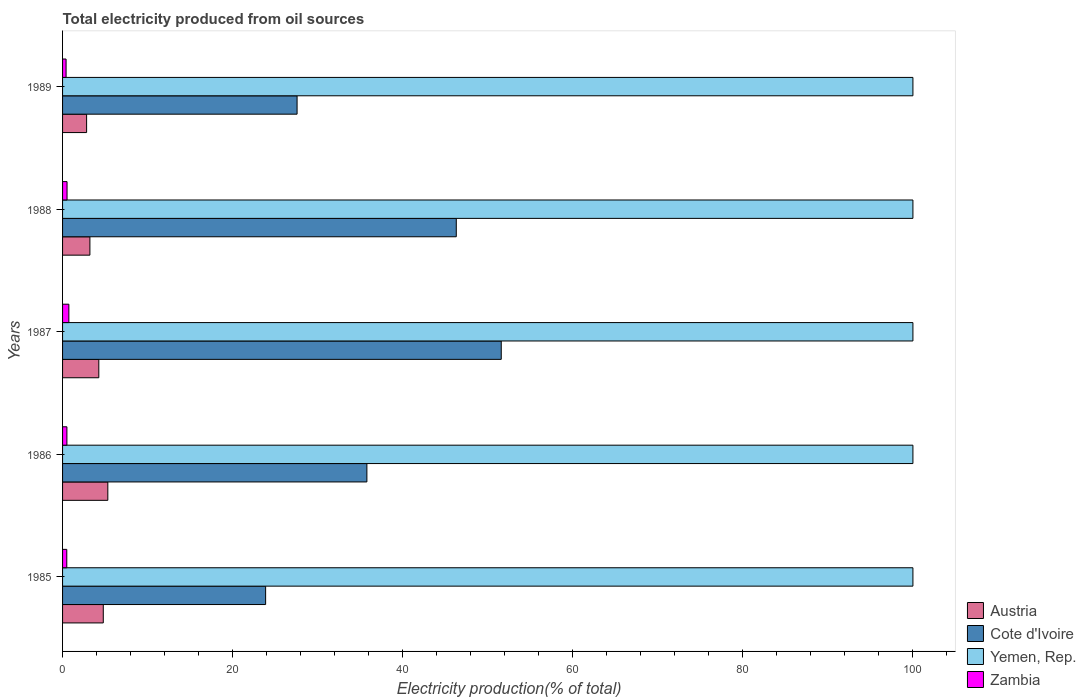How many different coloured bars are there?
Offer a very short reply. 4. Are the number of bars per tick equal to the number of legend labels?
Ensure brevity in your answer.  Yes. Are the number of bars on each tick of the Y-axis equal?
Provide a short and direct response. Yes. Across all years, what is the maximum total electricity produced in Cote d'Ivoire?
Your answer should be compact. 51.59. In which year was the total electricity produced in Yemen, Rep. minimum?
Provide a short and direct response. 1985. What is the total total electricity produced in Zambia in the graph?
Ensure brevity in your answer.  2.69. What is the difference between the total electricity produced in Austria in 1987 and the total electricity produced in Yemen, Rep. in 1986?
Provide a short and direct response. -95.74. What is the average total electricity produced in Austria per year?
Offer a terse response. 4.08. In the year 1987, what is the difference between the total electricity produced in Yemen, Rep. and total electricity produced in Zambia?
Your answer should be compact. 99.26. What is the ratio of the total electricity produced in Austria in 1985 to that in 1987?
Offer a very short reply. 1.12. Is the total electricity produced in Cote d'Ivoire in 1987 less than that in 1989?
Keep it short and to the point. No. Is the difference between the total electricity produced in Yemen, Rep. in 1987 and 1988 greater than the difference between the total electricity produced in Zambia in 1987 and 1988?
Your answer should be very brief. No. What is the difference between the highest and the second highest total electricity produced in Yemen, Rep.?
Make the answer very short. 0. What is the difference between the highest and the lowest total electricity produced in Zambia?
Offer a terse response. 0.33. In how many years, is the total electricity produced in Yemen, Rep. greater than the average total electricity produced in Yemen, Rep. taken over all years?
Offer a very short reply. 0. Is the sum of the total electricity produced in Austria in 1985 and 1988 greater than the maximum total electricity produced in Yemen, Rep. across all years?
Keep it short and to the point. No. Is it the case that in every year, the sum of the total electricity produced in Zambia and total electricity produced in Austria is greater than the sum of total electricity produced in Yemen, Rep. and total electricity produced in Cote d'Ivoire?
Ensure brevity in your answer.  Yes. What does the 2nd bar from the top in 1985 represents?
Offer a terse response. Yemen, Rep. What does the 2nd bar from the bottom in 1989 represents?
Ensure brevity in your answer.  Cote d'Ivoire. Is it the case that in every year, the sum of the total electricity produced in Yemen, Rep. and total electricity produced in Austria is greater than the total electricity produced in Cote d'Ivoire?
Give a very brief answer. Yes. How many bars are there?
Provide a succinct answer. 20. How many years are there in the graph?
Give a very brief answer. 5. Are the values on the major ticks of X-axis written in scientific E-notation?
Offer a very short reply. No. Does the graph contain any zero values?
Ensure brevity in your answer.  No. Does the graph contain grids?
Make the answer very short. No. Where does the legend appear in the graph?
Your answer should be compact. Bottom right. What is the title of the graph?
Provide a short and direct response. Total electricity produced from oil sources. Does "Equatorial Guinea" appear as one of the legend labels in the graph?
Your answer should be very brief. No. What is the label or title of the X-axis?
Ensure brevity in your answer.  Electricity production(% of total). What is the Electricity production(% of total) in Austria in 1985?
Ensure brevity in your answer.  4.79. What is the Electricity production(% of total) of Cote d'Ivoire in 1985?
Offer a terse response. 23.88. What is the Electricity production(% of total) in Yemen, Rep. in 1985?
Keep it short and to the point. 100. What is the Electricity production(% of total) of Zambia in 1985?
Your answer should be very brief. 0.5. What is the Electricity production(% of total) in Austria in 1986?
Your response must be concise. 5.32. What is the Electricity production(% of total) in Cote d'Ivoire in 1986?
Your answer should be very brief. 35.79. What is the Electricity production(% of total) in Yemen, Rep. in 1986?
Provide a succinct answer. 100. What is the Electricity production(% of total) in Zambia in 1986?
Your answer should be very brief. 0.51. What is the Electricity production(% of total) of Austria in 1987?
Your response must be concise. 4.26. What is the Electricity production(% of total) of Cote d'Ivoire in 1987?
Provide a short and direct response. 51.59. What is the Electricity production(% of total) in Zambia in 1987?
Make the answer very short. 0.74. What is the Electricity production(% of total) of Austria in 1988?
Keep it short and to the point. 3.22. What is the Electricity production(% of total) of Cote d'Ivoire in 1988?
Provide a succinct answer. 46.3. What is the Electricity production(% of total) in Yemen, Rep. in 1988?
Keep it short and to the point. 100. What is the Electricity production(% of total) in Zambia in 1988?
Offer a very short reply. 0.53. What is the Electricity production(% of total) in Austria in 1989?
Give a very brief answer. 2.83. What is the Electricity production(% of total) of Cote d'Ivoire in 1989?
Your answer should be compact. 27.58. What is the Electricity production(% of total) of Yemen, Rep. in 1989?
Provide a succinct answer. 100. What is the Electricity production(% of total) of Zambia in 1989?
Make the answer very short. 0.41. Across all years, what is the maximum Electricity production(% of total) of Austria?
Offer a terse response. 5.32. Across all years, what is the maximum Electricity production(% of total) in Cote d'Ivoire?
Ensure brevity in your answer.  51.59. Across all years, what is the maximum Electricity production(% of total) in Yemen, Rep.?
Give a very brief answer. 100. Across all years, what is the maximum Electricity production(% of total) of Zambia?
Offer a terse response. 0.74. Across all years, what is the minimum Electricity production(% of total) in Austria?
Ensure brevity in your answer.  2.83. Across all years, what is the minimum Electricity production(% of total) in Cote d'Ivoire?
Ensure brevity in your answer.  23.88. Across all years, what is the minimum Electricity production(% of total) of Yemen, Rep.?
Provide a short and direct response. 100. Across all years, what is the minimum Electricity production(% of total) in Zambia?
Your answer should be very brief. 0.41. What is the total Electricity production(% of total) in Austria in the graph?
Keep it short and to the point. 20.42. What is the total Electricity production(% of total) in Cote d'Ivoire in the graph?
Your response must be concise. 185.13. What is the total Electricity production(% of total) in Yemen, Rep. in the graph?
Your answer should be very brief. 500. What is the total Electricity production(% of total) of Zambia in the graph?
Ensure brevity in your answer.  2.69. What is the difference between the Electricity production(% of total) in Austria in 1985 and that in 1986?
Your answer should be compact. -0.54. What is the difference between the Electricity production(% of total) in Cote d'Ivoire in 1985 and that in 1986?
Your answer should be compact. -11.91. What is the difference between the Electricity production(% of total) in Yemen, Rep. in 1985 and that in 1986?
Make the answer very short. 0. What is the difference between the Electricity production(% of total) in Zambia in 1985 and that in 1986?
Your answer should be very brief. -0.01. What is the difference between the Electricity production(% of total) in Austria in 1985 and that in 1987?
Keep it short and to the point. 0.52. What is the difference between the Electricity production(% of total) of Cote d'Ivoire in 1985 and that in 1987?
Offer a terse response. -27.71. What is the difference between the Electricity production(% of total) in Yemen, Rep. in 1985 and that in 1987?
Your answer should be compact. 0. What is the difference between the Electricity production(% of total) in Zambia in 1985 and that in 1987?
Keep it short and to the point. -0.24. What is the difference between the Electricity production(% of total) in Austria in 1985 and that in 1988?
Ensure brevity in your answer.  1.57. What is the difference between the Electricity production(% of total) in Cote d'Ivoire in 1985 and that in 1988?
Your response must be concise. -22.42. What is the difference between the Electricity production(% of total) in Yemen, Rep. in 1985 and that in 1988?
Ensure brevity in your answer.  0. What is the difference between the Electricity production(% of total) in Zambia in 1985 and that in 1988?
Give a very brief answer. -0.03. What is the difference between the Electricity production(% of total) in Austria in 1985 and that in 1989?
Offer a terse response. 1.96. What is the difference between the Electricity production(% of total) in Cote d'Ivoire in 1985 and that in 1989?
Give a very brief answer. -3.7. What is the difference between the Electricity production(% of total) of Yemen, Rep. in 1985 and that in 1989?
Your answer should be very brief. 0. What is the difference between the Electricity production(% of total) in Zambia in 1985 and that in 1989?
Provide a short and direct response. 0.08. What is the difference between the Electricity production(% of total) of Austria in 1986 and that in 1987?
Ensure brevity in your answer.  1.06. What is the difference between the Electricity production(% of total) of Cote d'Ivoire in 1986 and that in 1987?
Make the answer very short. -15.8. What is the difference between the Electricity production(% of total) of Zambia in 1986 and that in 1987?
Ensure brevity in your answer.  -0.23. What is the difference between the Electricity production(% of total) of Austria in 1986 and that in 1988?
Provide a short and direct response. 2.11. What is the difference between the Electricity production(% of total) of Cote d'Ivoire in 1986 and that in 1988?
Ensure brevity in your answer.  -10.51. What is the difference between the Electricity production(% of total) of Yemen, Rep. in 1986 and that in 1988?
Offer a terse response. 0. What is the difference between the Electricity production(% of total) in Zambia in 1986 and that in 1988?
Ensure brevity in your answer.  -0.02. What is the difference between the Electricity production(% of total) of Austria in 1986 and that in 1989?
Keep it short and to the point. 2.5. What is the difference between the Electricity production(% of total) of Cote d'Ivoire in 1986 and that in 1989?
Keep it short and to the point. 8.21. What is the difference between the Electricity production(% of total) of Yemen, Rep. in 1986 and that in 1989?
Give a very brief answer. 0. What is the difference between the Electricity production(% of total) of Zambia in 1986 and that in 1989?
Ensure brevity in your answer.  0.1. What is the difference between the Electricity production(% of total) of Austria in 1987 and that in 1988?
Your response must be concise. 1.05. What is the difference between the Electricity production(% of total) in Cote d'Ivoire in 1987 and that in 1988?
Ensure brevity in your answer.  5.29. What is the difference between the Electricity production(% of total) in Yemen, Rep. in 1987 and that in 1988?
Give a very brief answer. 0. What is the difference between the Electricity production(% of total) of Zambia in 1987 and that in 1988?
Your answer should be very brief. 0.21. What is the difference between the Electricity production(% of total) of Austria in 1987 and that in 1989?
Make the answer very short. 1.43. What is the difference between the Electricity production(% of total) in Cote d'Ivoire in 1987 and that in 1989?
Give a very brief answer. 24.01. What is the difference between the Electricity production(% of total) of Yemen, Rep. in 1987 and that in 1989?
Give a very brief answer. 0. What is the difference between the Electricity production(% of total) in Zambia in 1987 and that in 1989?
Ensure brevity in your answer.  0.33. What is the difference between the Electricity production(% of total) in Austria in 1988 and that in 1989?
Offer a very short reply. 0.39. What is the difference between the Electricity production(% of total) of Cote d'Ivoire in 1988 and that in 1989?
Your answer should be compact. 18.72. What is the difference between the Electricity production(% of total) of Zambia in 1988 and that in 1989?
Provide a short and direct response. 0.11. What is the difference between the Electricity production(% of total) of Austria in 1985 and the Electricity production(% of total) of Cote d'Ivoire in 1986?
Offer a terse response. -31. What is the difference between the Electricity production(% of total) in Austria in 1985 and the Electricity production(% of total) in Yemen, Rep. in 1986?
Offer a very short reply. -95.21. What is the difference between the Electricity production(% of total) of Austria in 1985 and the Electricity production(% of total) of Zambia in 1986?
Keep it short and to the point. 4.28. What is the difference between the Electricity production(% of total) in Cote d'Ivoire in 1985 and the Electricity production(% of total) in Yemen, Rep. in 1986?
Provide a succinct answer. -76.12. What is the difference between the Electricity production(% of total) in Cote d'Ivoire in 1985 and the Electricity production(% of total) in Zambia in 1986?
Ensure brevity in your answer.  23.37. What is the difference between the Electricity production(% of total) in Yemen, Rep. in 1985 and the Electricity production(% of total) in Zambia in 1986?
Your answer should be very brief. 99.49. What is the difference between the Electricity production(% of total) in Austria in 1985 and the Electricity production(% of total) in Cote d'Ivoire in 1987?
Ensure brevity in your answer.  -46.8. What is the difference between the Electricity production(% of total) of Austria in 1985 and the Electricity production(% of total) of Yemen, Rep. in 1987?
Make the answer very short. -95.21. What is the difference between the Electricity production(% of total) of Austria in 1985 and the Electricity production(% of total) of Zambia in 1987?
Your answer should be compact. 4.05. What is the difference between the Electricity production(% of total) in Cote d'Ivoire in 1985 and the Electricity production(% of total) in Yemen, Rep. in 1987?
Keep it short and to the point. -76.12. What is the difference between the Electricity production(% of total) in Cote d'Ivoire in 1985 and the Electricity production(% of total) in Zambia in 1987?
Make the answer very short. 23.14. What is the difference between the Electricity production(% of total) of Yemen, Rep. in 1985 and the Electricity production(% of total) of Zambia in 1987?
Make the answer very short. 99.26. What is the difference between the Electricity production(% of total) in Austria in 1985 and the Electricity production(% of total) in Cote d'Ivoire in 1988?
Provide a short and direct response. -41.51. What is the difference between the Electricity production(% of total) in Austria in 1985 and the Electricity production(% of total) in Yemen, Rep. in 1988?
Keep it short and to the point. -95.21. What is the difference between the Electricity production(% of total) of Austria in 1985 and the Electricity production(% of total) of Zambia in 1988?
Make the answer very short. 4.26. What is the difference between the Electricity production(% of total) of Cote d'Ivoire in 1985 and the Electricity production(% of total) of Yemen, Rep. in 1988?
Your response must be concise. -76.12. What is the difference between the Electricity production(% of total) in Cote d'Ivoire in 1985 and the Electricity production(% of total) in Zambia in 1988?
Your response must be concise. 23.35. What is the difference between the Electricity production(% of total) in Yemen, Rep. in 1985 and the Electricity production(% of total) in Zambia in 1988?
Give a very brief answer. 99.47. What is the difference between the Electricity production(% of total) in Austria in 1985 and the Electricity production(% of total) in Cote d'Ivoire in 1989?
Your answer should be very brief. -22.79. What is the difference between the Electricity production(% of total) of Austria in 1985 and the Electricity production(% of total) of Yemen, Rep. in 1989?
Your answer should be very brief. -95.21. What is the difference between the Electricity production(% of total) of Austria in 1985 and the Electricity production(% of total) of Zambia in 1989?
Keep it short and to the point. 4.37. What is the difference between the Electricity production(% of total) in Cote d'Ivoire in 1985 and the Electricity production(% of total) in Yemen, Rep. in 1989?
Your response must be concise. -76.12. What is the difference between the Electricity production(% of total) of Cote d'Ivoire in 1985 and the Electricity production(% of total) of Zambia in 1989?
Your answer should be compact. 23.47. What is the difference between the Electricity production(% of total) of Yemen, Rep. in 1985 and the Electricity production(% of total) of Zambia in 1989?
Offer a terse response. 99.59. What is the difference between the Electricity production(% of total) in Austria in 1986 and the Electricity production(% of total) in Cote d'Ivoire in 1987?
Ensure brevity in your answer.  -46.26. What is the difference between the Electricity production(% of total) of Austria in 1986 and the Electricity production(% of total) of Yemen, Rep. in 1987?
Offer a terse response. -94.68. What is the difference between the Electricity production(% of total) of Austria in 1986 and the Electricity production(% of total) of Zambia in 1987?
Provide a succinct answer. 4.58. What is the difference between the Electricity production(% of total) of Cote d'Ivoire in 1986 and the Electricity production(% of total) of Yemen, Rep. in 1987?
Offer a very short reply. -64.21. What is the difference between the Electricity production(% of total) of Cote d'Ivoire in 1986 and the Electricity production(% of total) of Zambia in 1987?
Provide a succinct answer. 35.05. What is the difference between the Electricity production(% of total) in Yemen, Rep. in 1986 and the Electricity production(% of total) in Zambia in 1987?
Offer a very short reply. 99.26. What is the difference between the Electricity production(% of total) in Austria in 1986 and the Electricity production(% of total) in Cote d'Ivoire in 1988?
Ensure brevity in your answer.  -40.98. What is the difference between the Electricity production(% of total) in Austria in 1986 and the Electricity production(% of total) in Yemen, Rep. in 1988?
Provide a short and direct response. -94.68. What is the difference between the Electricity production(% of total) of Austria in 1986 and the Electricity production(% of total) of Zambia in 1988?
Ensure brevity in your answer.  4.8. What is the difference between the Electricity production(% of total) of Cote d'Ivoire in 1986 and the Electricity production(% of total) of Yemen, Rep. in 1988?
Give a very brief answer. -64.21. What is the difference between the Electricity production(% of total) in Cote d'Ivoire in 1986 and the Electricity production(% of total) in Zambia in 1988?
Keep it short and to the point. 35.26. What is the difference between the Electricity production(% of total) in Yemen, Rep. in 1986 and the Electricity production(% of total) in Zambia in 1988?
Offer a terse response. 99.47. What is the difference between the Electricity production(% of total) of Austria in 1986 and the Electricity production(% of total) of Cote d'Ivoire in 1989?
Make the answer very short. -22.26. What is the difference between the Electricity production(% of total) of Austria in 1986 and the Electricity production(% of total) of Yemen, Rep. in 1989?
Your answer should be compact. -94.68. What is the difference between the Electricity production(% of total) in Austria in 1986 and the Electricity production(% of total) in Zambia in 1989?
Your answer should be compact. 4.91. What is the difference between the Electricity production(% of total) of Cote d'Ivoire in 1986 and the Electricity production(% of total) of Yemen, Rep. in 1989?
Your answer should be compact. -64.21. What is the difference between the Electricity production(% of total) of Cote d'Ivoire in 1986 and the Electricity production(% of total) of Zambia in 1989?
Your answer should be compact. 35.37. What is the difference between the Electricity production(% of total) of Yemen, Rep. in 1986 and the Electricity production(% of total) of Zambia in 1989?
Your answer should be very brief. 99.59. What is the difference between the Electricity production(% of total) in Austria in 1987 and the Electricity production(% of total) in Cote d'Ivoire in 1988?
Provide a short and direct response. -42.04. What is the difference between the Electricity production(% of total) in Austria in 1987 and the Electricity production(% of total) in Yemen, Rep. in 1988?
Offer a very short reply. -95.74. What is the difference between the Electricity production(% of total) of Austria in 1987 and the Electricity production(% of total) of Zambia in 1988?
Your response must be concise. 3.73. What is the difference between the Electricity production(% of total) of Cote d'Ivoire in 1987 and the Electricity production(% of total) of Yemen, Rep. in 1988?
Provide a succinct answer. -48.41. What is the difference between the Electricity production(% of total) of Cote d'Ivoire in 1987 and the Electricity production(% of total) of Zambia in 1988?
Your answer should be very brief. 51.06. What is the difference between the Electricity production(% of total) of Yemen, Rep. in 1987 and the Electricity production(% of total) of Zambia in 1988?
Your answer should be very brief. 99.47. What is the difference between the Electricity production(% of total) of Austria in 1987 and the Electricity production(% of total) of Cote d'Ivoire in 1989?
Ensure brevity in your answer.  -23.32. What is the difference between the Electricity production(% of total) of Austria in 1987 and the Electricity production(% of total) of Yemen, Rep. in 1989?
Offer a very short reply. -95.74. What is the difference between the Electricity production(% of total) in Austria in 1987 and the Electricity production(% of total) in Zambia in 1989?
Your answer should be very brief. 3.85. What is the difference between the Electricity production(% of total) in Cote d'Ivoire in 1987 and the Electricity production(% of total) in Yemen, Rep. in 1989?
Give a very brief answer. -48.41. What is the difference between the Electricity production(% of total) in Cote d'Ivoire in 1987 and the Electricity production(% of total) in Zambia in 1989?
Your response must be concise. 51.17. What is the difference between the Electricity production(% of total) in Yemen, Rep. in 1987 and the Electricity production(% of total) in Zambia in 1989?
Give a very brief answer. 99.59. What is the difference between the Electricity production(% of total) in Austria in 1988 and the Electricity production(% of total) in Cote d'Ivoire in 1989?
Keep it short and to the point. -24.36. What is the difference between the Electricity production(% of total) of Austria in 1988 and the Electricity production(% of total) of Yemen, Rep. in 1989?
Offer a terse response. -96.78. What is the difference between the Electricity production(% of total) in Austria in 1988 and the Electricity production(% of total) in Zambia in 1989?
Your response must be concise. 2.8. What is the difference between the Electricity production(% of total) of Cote d'Ivoire in 1988 and the Electricity production(% of total) of Yemen, Rep. in 1989?
Offer a terse response. -53.7. What is the difference between the Electricity production(% of total) of Cote d'Ivoire in 1988 and the Electricity production(% of total) of Zambia in 1989?
Offer a terse response. 45.89. What is the difference between the Electricity production(% of total) in Yemen, Rep. in 1988 and the Electricity production(% of total) in Zambia in 1989?
Your answer should be very brief. 99.59. What is the average Electricity production(% of total) in Austria per year?
Give a very brief answer. 4.08. What is the average Electricity production(% of total) of Cote d'Ivoire per year?
Provide a succinct answer. 37.03. What is the average Electricity production(% of total) of Yemen, Rep. per year?
Provide a succinct answer. 100. What is the average Electricity production(% of total) of Zambia per year?
Offer a very short reply. 0.54. In the year 1985, what is the difference between the Electricity production(% of total) of Austria and Electricity production(% of total) of Cote d'Ivoire?
Ensure brevity in your answer.  -19.09. In the year 1985, what is the difference between the Electricity production(% of total) of Austria and Electricity production(% of total) of Yemen, Rep.?
Your answer should be compact. -95.21. In the year 1985, what is the difference between the Electricity production(% of total) of Austria and Electricity production(% of total) of Zambia?
Provide a succinct answer. 4.29. In the year 1985, what is the difference between the Electricity production(% of total) in Cote d'Ivoire and Electricity production(% of total) in Yemen, Rep.?
Your response must be concise. -76.12. In the year 1985, what is the difference between the Electricity production(% of total) of Cote d'Ivoire and Electricity production(% of total) of Zambia?
Your answer should be compact. 23.38. In the year 1985, what is the difference between the Electricity production(% of total) of Yemen, Rep. and Electricity production(% of total) of Zambia?
Offer a terse response. 99.5. In the year 1986, what is the difference between the Electricity production(% of total) in Austria and Electricity production(% of total) in Cote d'Ivoire?
Your answer should be very brief. -30.46. In the year 1986, what is the difference between the Electricity production(% of total) in Austria and Electricity production(% of total) in Yemen, Rep.?
Your answer should be compact. -94.68. In the year 1986, what is the difference between the Electricity production(% of total) in Austria and Electricity production(% of total) in Zambia?
Provide a succinct answer. 4.81. In the year 1986, what is the difference between the Electricity production(% of total) of Cote d'Ivoire and Electricity production(% of total) of Yemen, Rep.?
Your answer should be compact. -64.21. In the year 1986, what is the difference between the Electricity production(% of total) in Cote d'Ivoire and Electricity production(% of total) in Zambia?
Provide a short and direct response. 35.28. In the year 1986, what is the difference between the Electricity production(% of total) of Yemen, Rep. and Electricity production(% of total) of Zambia?
Your answer should be compact. 99.49. In the year 1987, what is the difference between the Electricity production(% of total) in Austria and Electricity production(% of total) in Cote d'Ivoire?
Give a very brief answer. -47.33. In the year 1987, what is the difference between the Electricity production(% of total) of Austria and Electricity production(% of total) of Yemen, Rep.?
Provide a short and direct response. -95.74. In the year 1987, what is the difference between the Electricity production(% of total) in Austria and Electricity production(% of total) in Zambia?
Make the answer very short. 3.52. In the year 1987, what is the difference between the Electricity production(% of total) of Cote d'Ivoire and Electricity production(% of total) of Yemen, Rep.?
Keep it short and to the point. -48.41. In the year 1987, what is the difference between the Electricity production(% of total) of Cote d'Ivoire and Electricity production(% of total) of Zambia?
Offer a terse response. 50.85. In the year 1987, what is the difference between the Electricity production(% of total) in Yemen, Rep. and Electricity production(% of total) in Zambia?
Offer a terse response. 99.26. In the year 1988, what is the difference between the Electricity production(% of total) of Austria and Electricity production(% of total) of Cote d'Ivoire?
Your answer should be compact. -43.09. In the year 1988, what is the difference between the Electricity production(% of total) in Austria and Electricity production(% of total) in Yemen, Rep.?
Provide a succinct answer. -96.78. In the year 1988, what is the difference between the Electricity production(% of total) of Austria and Electricity production(% of total) of Zambia?
Your answer should be very brief. 2.69. In the year 1988, what is the difference between the Electricity production(% of total) of Cote d'Ivoire and Electricity production(% of total) of Yemen, Rep.?
Make the answer very short. -53.7. In the year 1988, what is the difference between the Electricity production(% of total) in Cote d'Ivoire and Electricity production(% of total) in Zambia?
Offer a very short reply. 45.77. In the year 1988, what is the difference between the Electricity production(% of total) in Yemen, Rep. and Electricity production(% of total) in Zambia?
Provide a short and direct response. 99.47. In the year 1989, what is the difference between the Electricity production(% of total) in Austria and Electricity production(% of total) in Cote d'Ivoire?
Keep it short and to the point. -24.75. In the year 1989, what is the difference between the Electricity production(% of total) in Austria and Electricity production(% of total) in Yemen, Rep.?
Ensure brevity in your answer.  -97.17. In the year 1989, what is the difference between the Electricity production(% of total) in Austria and Electricity production(% of total) in Zambia?
Offer a very short reply. 2.41. In the year 1989, what is the difference between the Electricity production(% of total) in Cote d'Ivoire and Electricity production(% of total) in Yemen, Rep.?
Keep it short and to the point. -72.42. In the year 1989, what is the difference between the Electricity production(% of total) in Cote d'Ivoire and Electricity production(% of total) in Zambia?
Your response must be concise. 27.16. In the year 1989, what is the difference between the Electricity production(% of total) in Yemen, Rep. and Electricity production(% of total) in Zambia?
Your answer should be compact. 99.59. What is the ratio of the Electricity production(% of total) of Austria in 1985 to that in 1986?
Your answer should be very brief. 0.9. What is the ratio of the Electricity production(% of total) of Cote d'Ivoire in 1985 to that in 1986?
Offer a very short reply. 0.67. What is the ratio of the Electricity production(% of total) in Zambia in 1985 to that in 1986?
Give a very brief answer. 0.97. What is the ratio of the Electricity production(% of total) of Austria in 1985 to that in 1987?
Give a very brief answer. 1.12. What is the ratio of the Electricity production(% of total) in Cote d'Ivoire in 1985 to that in 1987?
Ensure brevity in your answer.  0.46. What is the ratio of the Electricity production(% of total) in Zambia in 1985 to that in 1987?
Keep it short and to the point. 0.67. What is the ratio of the Electricity production(% of total) in Austria in 1985 to that in 1988?
Make the answer very short. 1.49. What is the ratio of the Electricity production(% of total) of Cote d'Ivoire in 1985 to that in 1988?
Your response must be concise. 0.52. What is the ratio of the Electricity production(% of total) in Yemen, Rep. in 1985 to that in 1988?
Your response must be concise. 1. What is the ratio of the Electricity production(% of total) in Zambia in 1985 to that in 1988?
Give a very brief answer. 0.94. What is the ratio of the Electricity production(% of total) in Austria in 1985 to that in 1989?
Keep it short and to the point. 1.69. What is the ratio of the Electricity production(% of total) of Cote d'Ivoire in 1985 to that in 1989?
Your answer should be very brief. 0.87. What is the ratio of the Electricity production(% of total) in Yemen, Rep. in 1985 to that in 1989?
Give a very brief answer. 1. What is the ratio of the Electricity production(% of total) of Zambia in 1985 to that in 1989?
Offer a very short reply. 1.2. What is the ratio of the Electricity production(% of total) of Austria in 1986 to that in 1987?
Your response must be concise. 1.25. What is the ratio of the Electricity production(% of total) in Cote d'Ivoire in 1986 to that in 1987?
Your response must be concise. 0.69. What is the ratio of the Electricity production(% of total) of Yemen, Rep. in 1986 to that in 1987?
Your answer should be compact. 1. What is the ratio of the Electricity production(% of total) in Zambia in 1986 to that in 1987?
Keep it short and to the point. 0.69. What is the ratio of the Electricity production(% of total) in Austria in 1986 to that in 1988?
Offer a very short reply. 1.66. What is the ratio of the Electricity production(% of total) in Cote d'Ivoire in 1986 to that in 1988?
Keep it short and to the point. 0.77. What is the ratio of the Electricity production(% of total) of Zambia in 1986 to that in 1988?
Offer a very short reply. 0.97. What is the ratio of the Electricity production(% of total) of Austria in 1986 to that in 1989?
Your answer should be compact. 1.88. What is the ratio of the Electricity production(% of total) of Cote d'Ivoire in 1986 to that in 1989?
Make the answer very short. 1.3. What is the ratio of the Electricity production(% of total) in Yemen, Rep. in 1986 to that in 1989?
Your answer should be compact. 1. What is the ratio of the Electricity production(% of total) in Zambia in 1986 to that in 1989?
Ensure brevity in your answer.  1.24. What is the ratio of the Electricity production(% of total) in Austria in 1987 to that in 1988?
Provide a succinct answer. 1.33. What is the ratio of the Electricity production(% of total) of Cote d'Ivoire in 1987 to that in 1988?
Your answer should be compact. 1.11. What is the ratio of the Electricity production(% of total) in Zambia in 1987 to that in 1988?
Keep it short and to the point. 1.4. What is the ratio of the Electricity production(% of total) of Austria in 1987 to that in 1989?
Keep it short and to the point. 1.51. What is the ratio of the Electricity production(% of total) of Cote d'Ivoire in 1987 to that in 1989?
Give a very brief answer. 1.87. What is the ratio of the Electricity production(% of total) in Yemen, Rep. in 1987 to that in 1989?
Offer a very short reply. 1. What is the ratio of the Electricity production(% of total) of Zambia in 1987 to that in 1989?
Offer a terse response. 1.79. What is the ratio of the Electricity production(% of total) of Austria in 1988 to that in 1989?
Your response must be concise. 1.14. What is the ratio of the Electricity production(% of total) in Cote d'Ivoire in 1988 to that in 1989?
Offer a very short reply. 1.68. What is the ratio of the Electricity production(% of total) of Zambia in 1988 to that in 1989?
Keep it short and to the point. 1.28. What is the difference between the highest and the second highest Electricity production(% of total) in Austria?
Provide a short and direct response. 0.54. What is the difference between the highest and the second highest Electricity production(% of total) of Cote d'Ivoire?
Provide a short and direct response. 5.29. What is the difference between the highest and the second highest Electricity production(% of total) of Yemen, Rep.?
Your answer should be compact. 0. What is the difference between the highest and the second highest Electricity production(% of total) of Zambia?
Offer a very short reply. 0.21. What is the difference between the highest and the lowest Electricity production(% of total) of Austria?
Offer a terse response. 2.5. What is the difference between the highest and the lowest Electricity production(% of total) of Cote d'Ivoire?
Make the answer very short. 27.71. What is the difference between the highest and the lowest Electricity production(% of total) of Zambia?
Give a very brief answer. 0.33. 